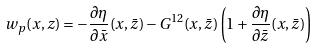<formula> <loc_0><loc_0><loc_500><loc_500>w _ { p } ( x , z ) = - \frac { \partial \eta } { \partial { \bar { x } } } ( x , \bar { z } ) - G ^ { 1 2 } ( x , \bar { z } ) \left ( 1 + \frac { \partial \eta } { \partial { \bar { z } } } ( x , \bar { z } ) \right )</formula> 